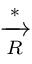Convert formula to latex. <formula><loc_0><loc_0><loc_500><loc_500>\xrightarrow [ { R } ] { * }</formula> 